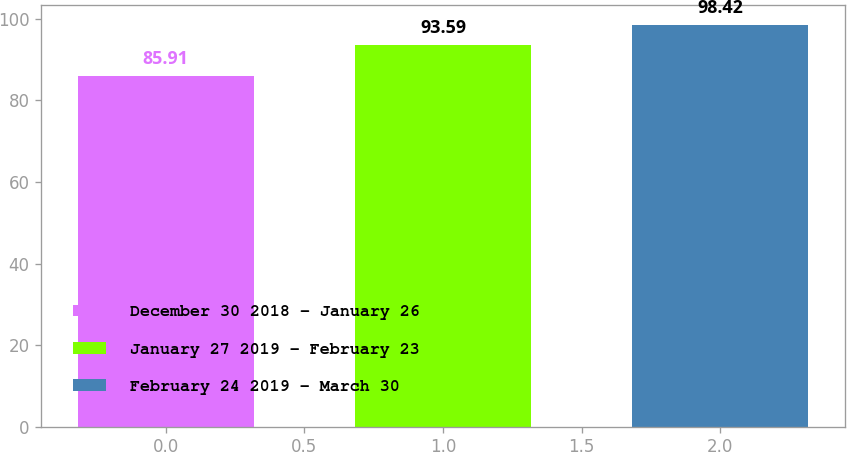Convert chart to OTSL. <chart><loc_0><loc_0><loc_500><loc_500><bar_chart><fcel>December 30 2018 - January 26<fcel>January 27 2019 - February 23<fcel>February 24 2019 - March 30<nl><fcel>85.91<fcel>93.59<fcel>98.42<nl></chart> 